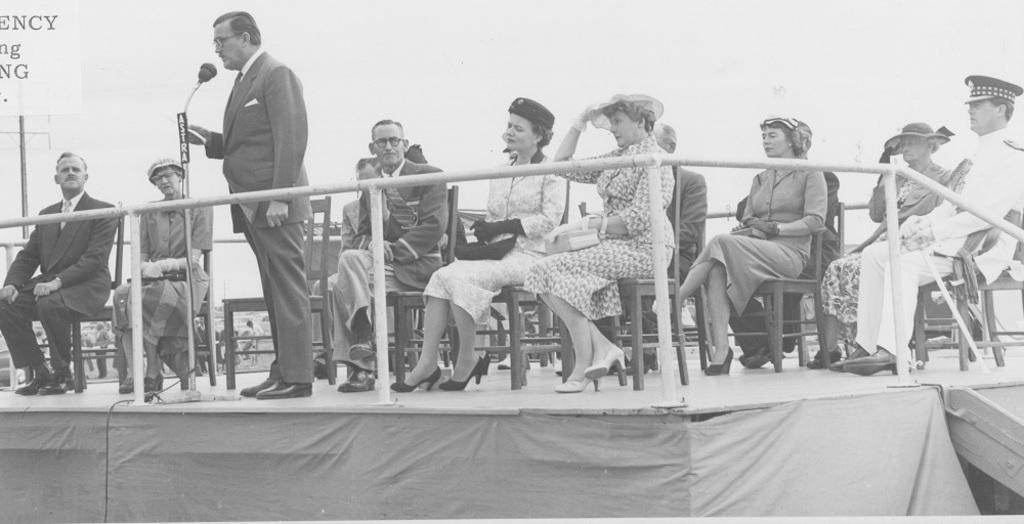What is the person in the image doing? The person is standing and speaking into a microphone. What can be inferred about the setting of the image? The presence of people seated on chairs on a stage suggests that the person is likely giving a speech or presentation. Where are the people on the stage located in relation to the person speaking into the microphone? The people on the stage are behind the person speaking into the microphone. What type of breakfast is being served on the stage in the image? There is no breakfast or food visible in the image; it features a person speaking into a microphone and people seated on chairs on a stage. 